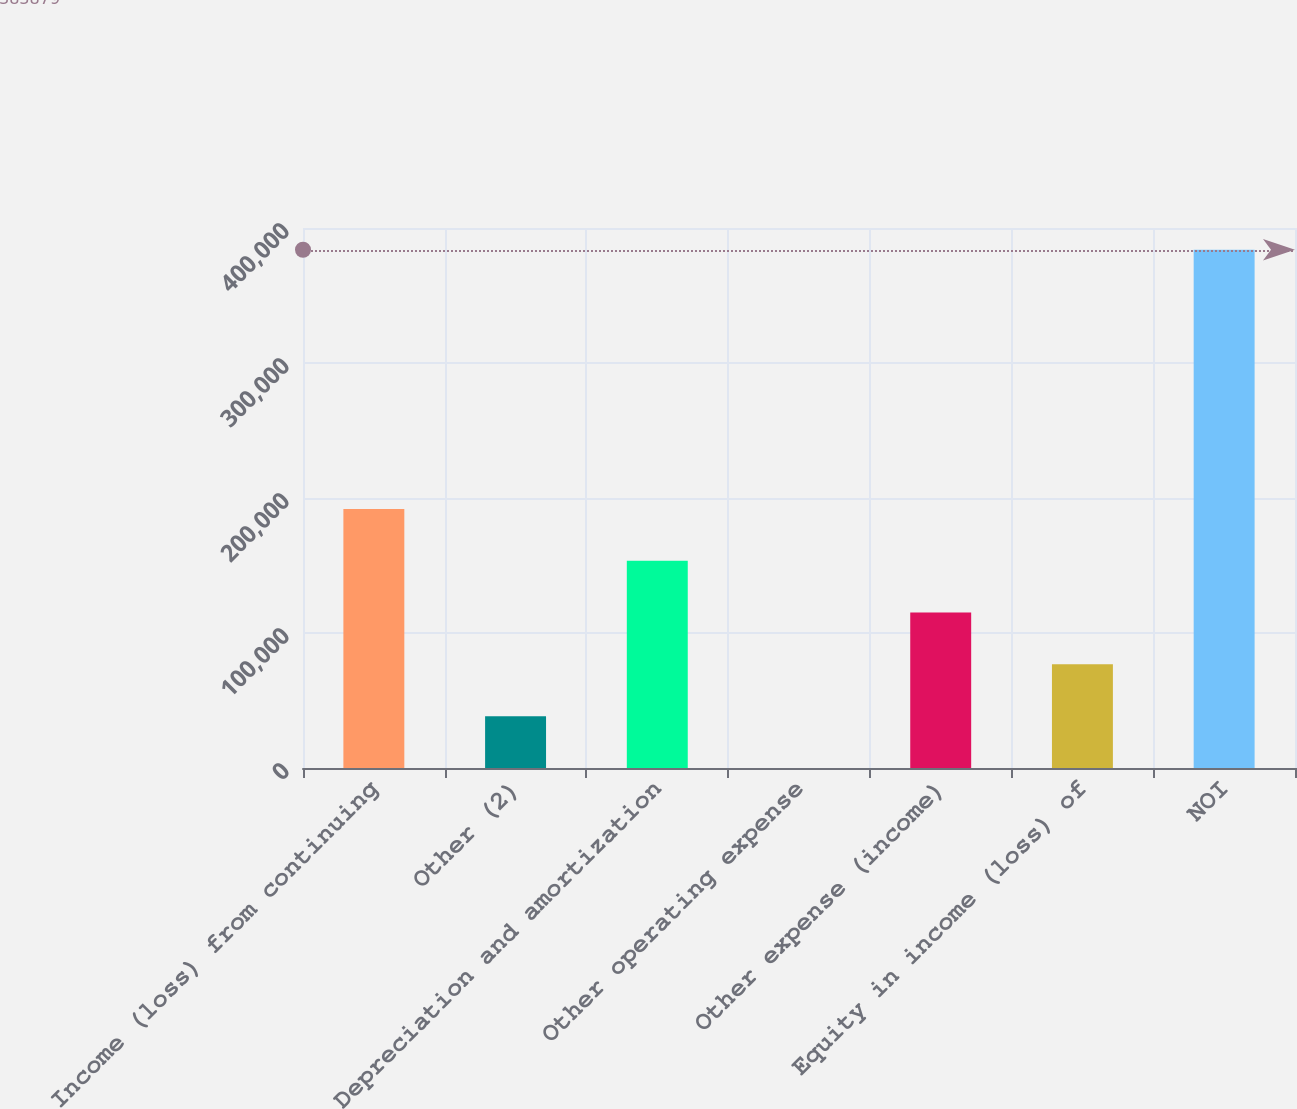Convert chart. <chart><loc_0><loc_0><loc_500><loc_500><bar_chart><fcel>Income (loss) from continuing<fcel>Other (2)<fcel>Depreciation and amortization<fcel>Other operating expense<fcel>Other expense (income)<fcel>Equity in income (loss) of<fcel>NOI<nl><fcel>191944<fcel>38396<fcel>153557<fcel>9<fcel>115170<fcel>76783<fcel>383879<nl></chart> 